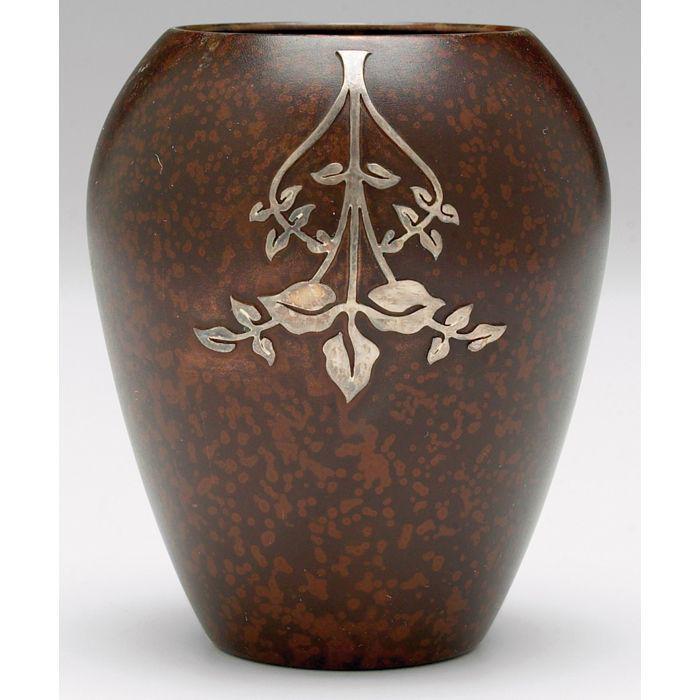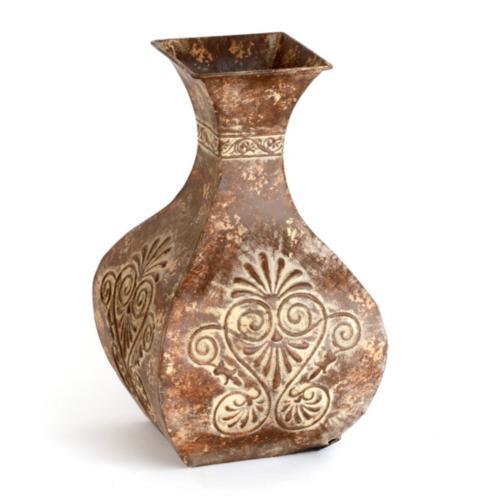The first image is the image on the left, the second image is the image on the right. Examine the images to the left and right. Is the description "There is an artistic ceramic vase with decorative patterns in the center of each image." accurate? Answer yes or no. Yes. The first image is the image on the left, the second image is the image on the right. For the images shown, is this caption "In one image the vase has a square tip and in the other the vase has a convex body" true? Answer yes or no. Yes. 